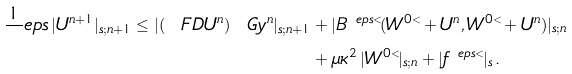Convert formula to latex. <formula><loc_0><loc_0><loc_500><loc_500>\frac { 1 } { \ } e p s \, | U ^ { n + 1 } | _ { s ; n + 1 } \leq | ( \ F D U ^ { n } ) \ G y ^ { n } | _ { s ; n + 1 } & + | B ^ { \ e p s < } ( W ^ { 0 < } + U ^ { n } , W ^ { 0 < } + U ^ { n } ) | _ { s ; n } \\ & + \mu \kappa ^ { 2 } \, | W ^ { 0 < } | _ { s ; n } + | f ^ { \ e p s < } | _ { s } \, .</formula> 